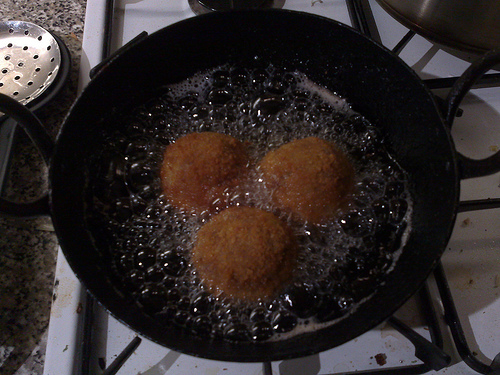<image>
Is there a pan under the food? Yes. The pan is positioned underneath the food, with the food above it in the vertical space. 